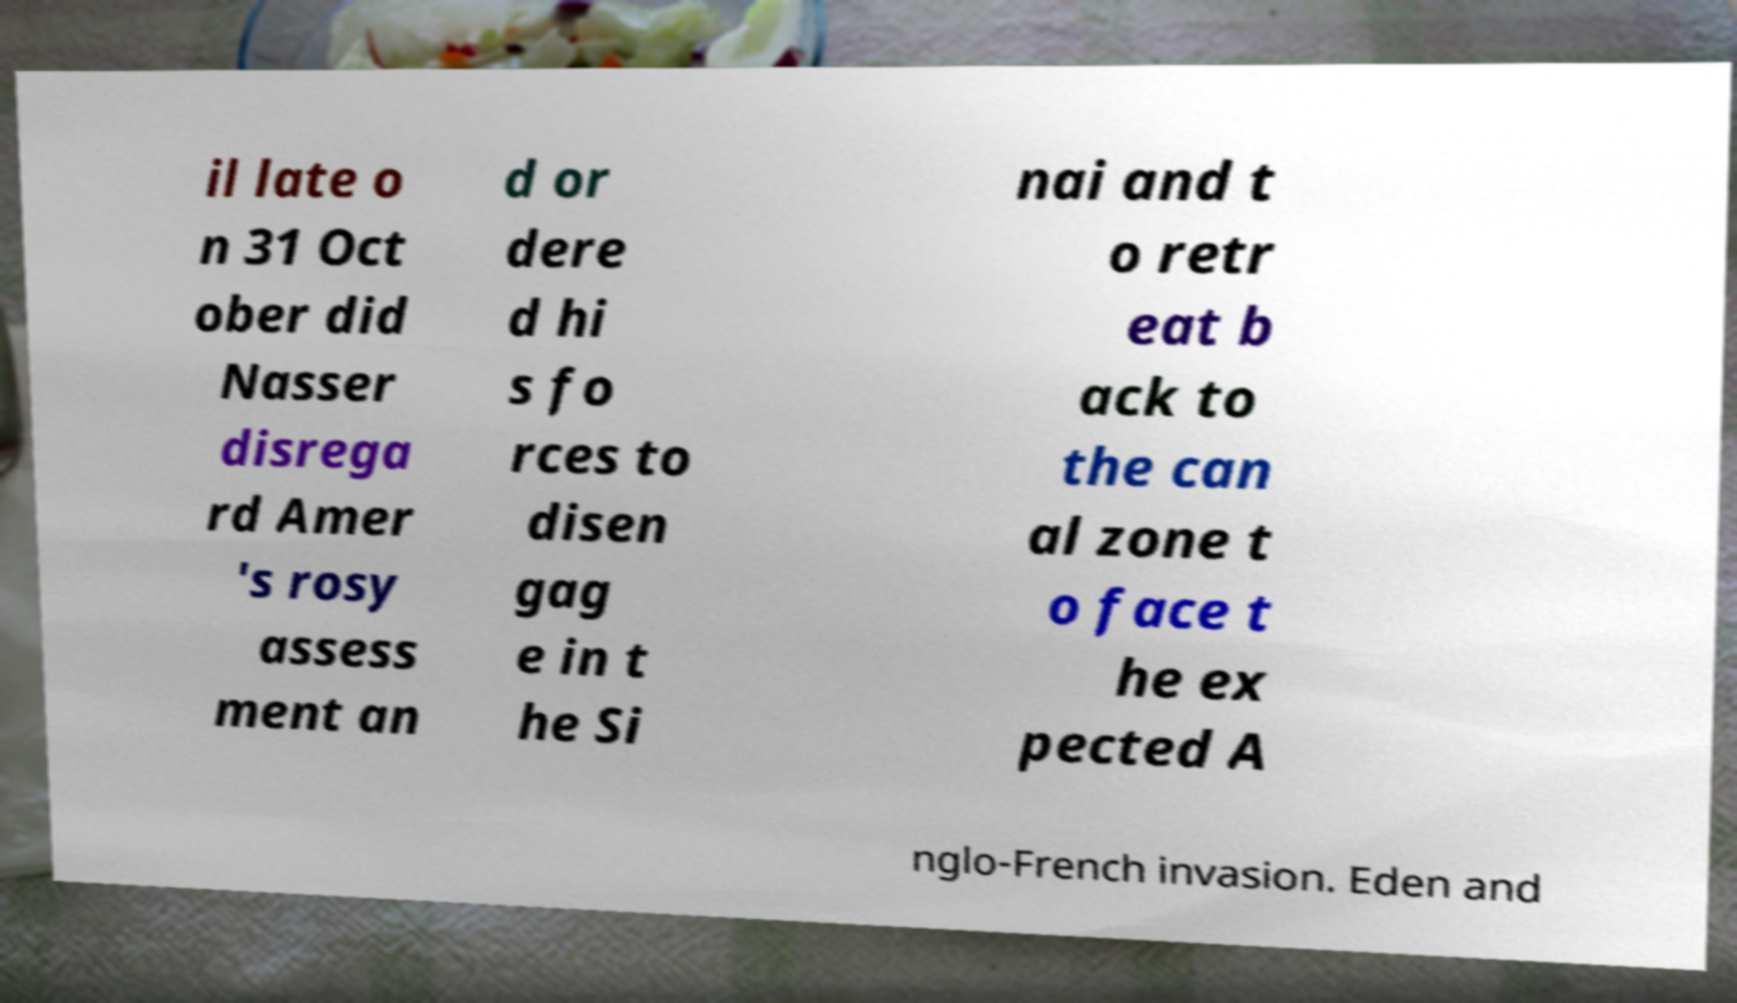There's text embedded in this image that I need extracted. Can you transcribe it verbatim? il late o n 31 Oct ober did Nasser disrega rd Amer 's rosy assess ment an d or dere d hi s fo rces to disen gag e in t he Si nai and t o retr eat b ack to the can al zone t o face t he ex pected A nglo-French invasion. Eden and 